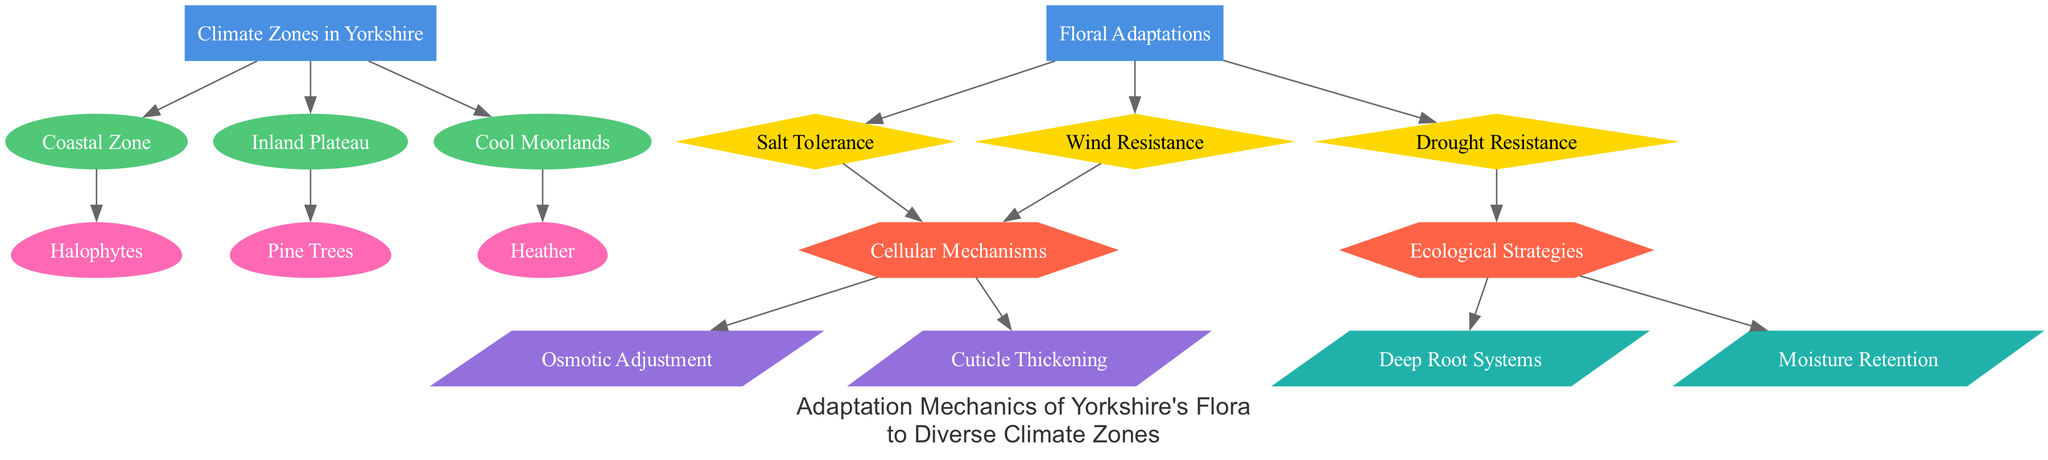What are the three climate zones in Yorkshire? The diagram includes three climate zones: coastal zone, inland plateau, and cool moorlands, which are explicitly mentioned as nodes connected to the main climate zones node.
Answer: coastal zone, inland plateau, cool moorlands How many floral adaptations are shown in the diagram? The diagram presents three floral adaptations: salt tolerance, wind resistance, and drought resistance, which can be counted directly from the adaptation nodes connected to the floral adaptations node.
Answer: 3 Which flora is associated with the coastal zone? The diagram indicates that halophytes are connected specifically to the coastal zone node, signifying its adaptation to the specific conditions present there.
Answer: Halophytes What cellular mechanism relates to salt tolerance? The diagram illustrates direct connections between salt tolerance and two cellular mechanisms: osmotic adjustment and cuticle thickening. By examining these connections, it's clear that osmotic adjustment is the relevant cellular mechanism for salt tolerance.
Answer: Osmotic Adjustment What ecological strategy is linked to drought resistance? Upon analyzing the diagram, we see that drought resistance is connected to two ecological strategies: deep root systems and moisture retention, indicating that these strategies are employed by plants to withstand drought conditions.
Answer: Deep Root Systems, Moisture Retention How many edges connect the floral adaptations to cellular mechanisms? The diagram shows two edges connecting floral adaptations (via salt tolerance and wind resistance) to cellular mechanisms, specifically demonstrating that floral adaptations are associated with their cellular strategies.
Answer: 2 Which floral adaptation is specifically connected to wind resistance? The diagram clearly outlines that wind resistance is linked to the category of cellular mechanisms, established by following the edge connections, which indicate that it leads to various cellular adaptation types.
Answer: Cellular Mechanisms What type of adaptation are halophytes characterized by? Analyzing the edges, halophytes are specifically connected to salt tolerance, indicating they possess adaptations that help them survive in high-salt environments, making salt tolerance the defining trait of halophytes.
Answer: Salt Tolerance 